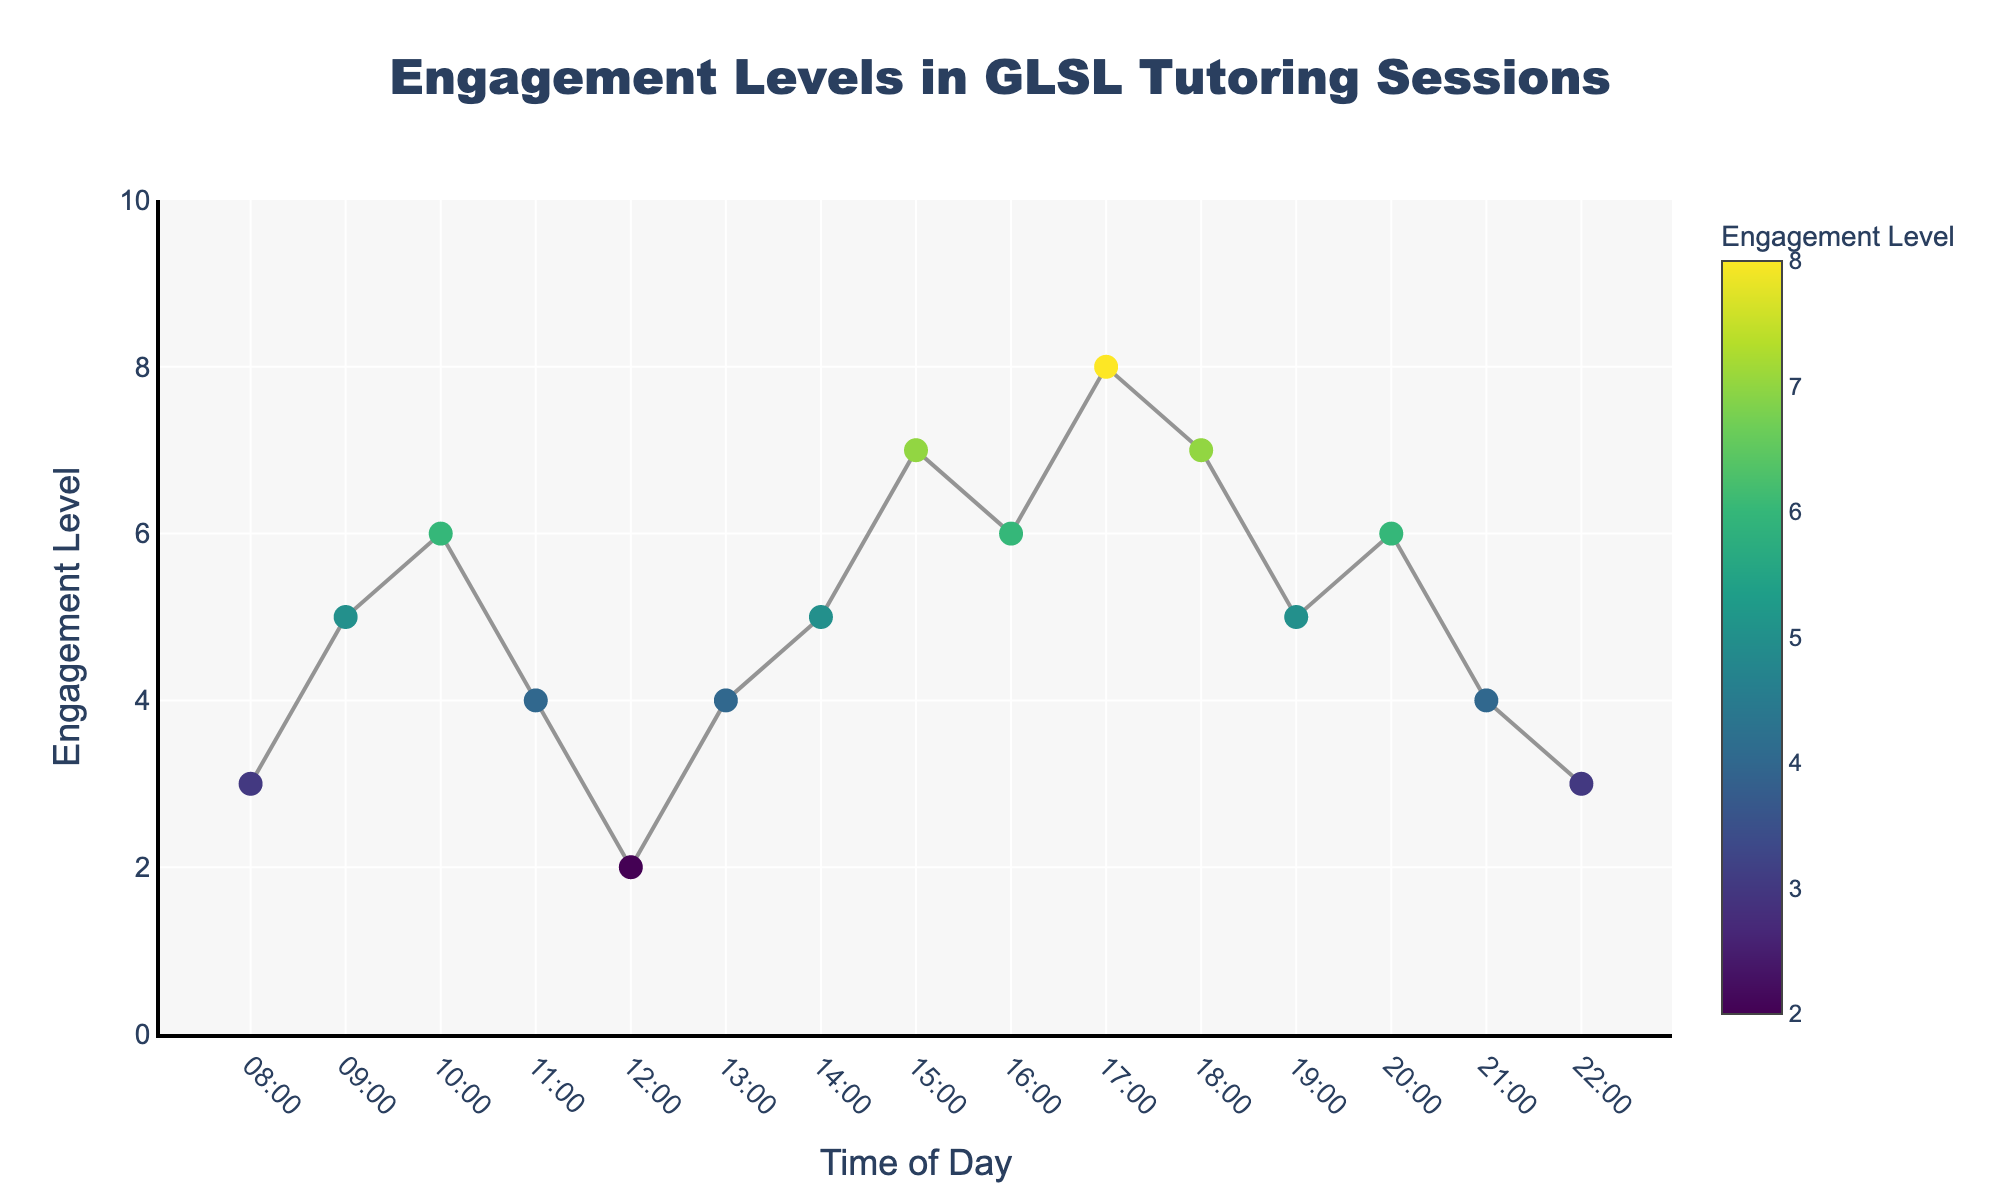What is the title of the scatter plot? The title can be found at the top of the plot. It describes the content of the scatter plot.
Answer: Engagement Levels in GLSL Tutoring Sessions What time of day has the highest engagement level? By examining the y-values (Engagement Level), we can identify the time point with the maximum y-value. The highest engagement level is 8, observed at 17:00.
Answer: 17:00 What is the range of engagement levels displayed on the y-axis? The range can be identified by looking at the y-axis labels. It starts at 0 and ends at 10.
Answer: 0 to 10 How does the engagement level change from 08:00 to 12:00? To compare these time points, observe the engagement levels at 08:00, 09:00, 10:00, 11:00, and 12:00. The levels are 3, 5, 6, 4, and 2, respectively.
Answer: It increases from 08:00 to 10:00, then decreases from 11:00 to 12:00 Which time of day has the lowest engagement level? By finding the lowest y-value, we see that the minimum engagement level of 2 occurs at 12:00.
Answer: 12:00 How many hours have an engagement level of 5? Identify and count the points where the y-value is 5. These points are at 09:00, 14:00, and 19:00, totaling 3 hours.
Answer: 3 hours What is the average engagement level from 18:00 to 22:00? Sum the engagement levels (7+5+6+4+3) and divide by the number of data points (5). (7+5+6+4+3)/5 = 25/5 = 5
Answer: 5 During what time does the engagement level drop below 4, and how many hours are affected? Engagement levels of 3 or below occur at 08:00 (3), 12:00 (2), and 22:00 (3). Count these times as 3 hours.
Answer: 3 hours What is the overall trend of engagement levels throughout the day? Identify the general pattern by observing the line connecting the points. Engagement initially increases, decreases around noon, peaks in the evening, and decreases again at night.
Answer: Increases in the morning, dips at noon, peaks in the evening, and decreases at night Which periods have engagement levels equal to 6? Look for data points with engagement levels of 6 at 10:00, 16:00, and 20:00.
Answer: 10:00, 16:00, 20:00 